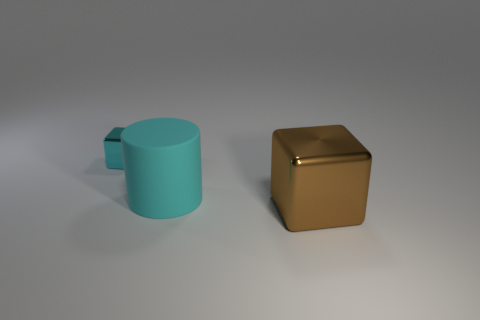Add 2 small metal blocks. How many objects exist? 5 Subtract all cubes. How many objects are left? 1 Subtract all brown blocks. How many blocks are left? 1 Add 1 large blue balls. How many large blue balls exist? 1 Subtract 1 cyan cubes. How many objects are left? 2 Subtract all red blocks. Subtract all blue cylinders. How many blocks are left? 2 Subtract all large shiny cubes. Subtract all brown metal things. How many objects are left? 1 Add 2 small cyan metallic cubes. How many small cyan metallic cubes are left? 3 